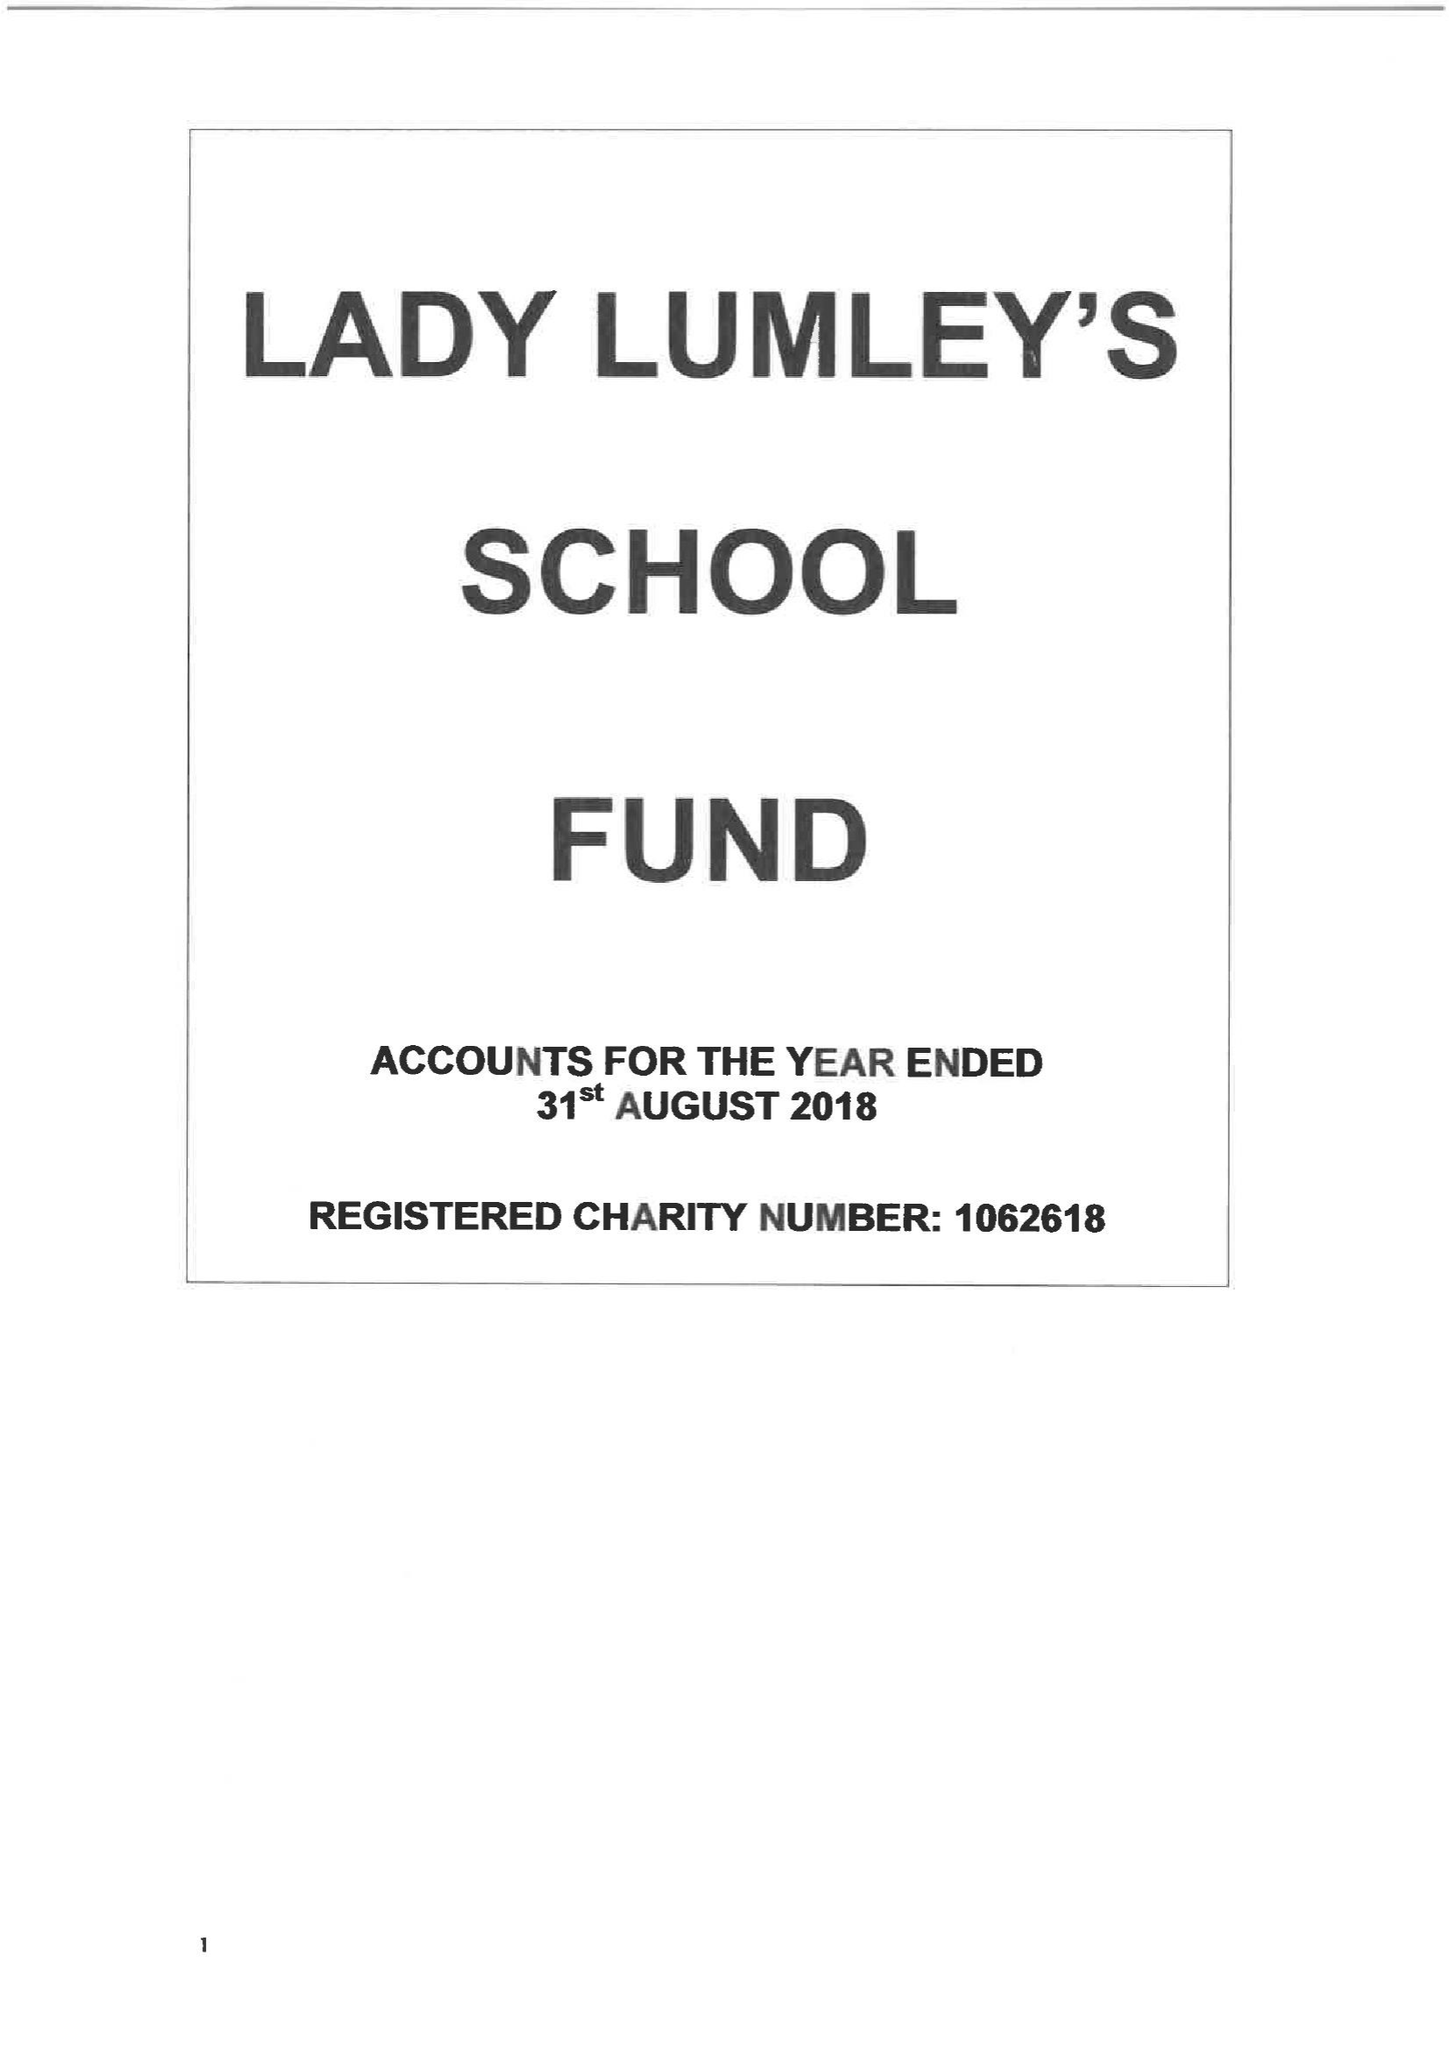What is the value for the address__postcode?
Answer the question using a single word or phrase. YO18 8NG 